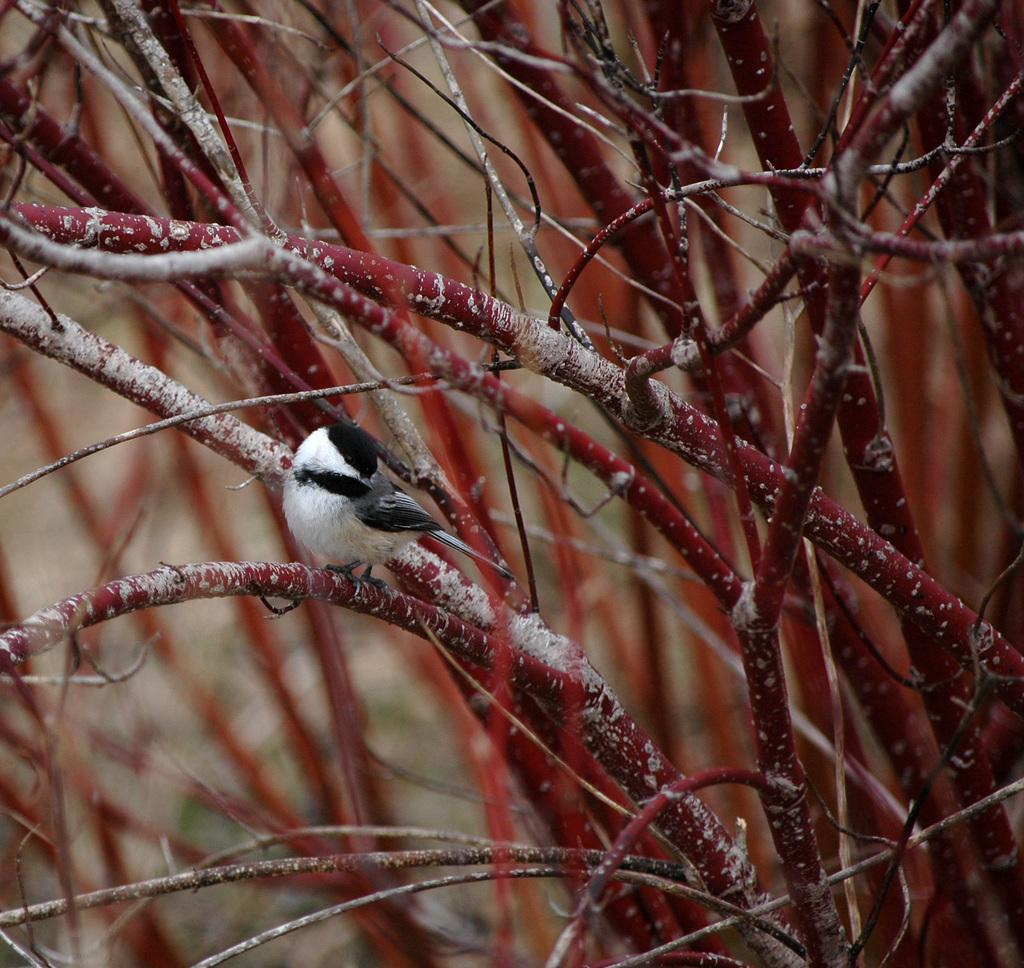What type of animal is present in the image? There is a bird in the image. What is the color scheme of the image? The image is in black and white. What can be seen in the background of the image? There are plants and red-colored stems in the background of the image. How much was the payment for the tent in the image? There is no tent or payment mentioned in the image; it features a bird and plants in a black and white setting. 